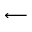<formula> <loc_0><loc_0><loc_500><loc_500>\longleftarrow</formula> 